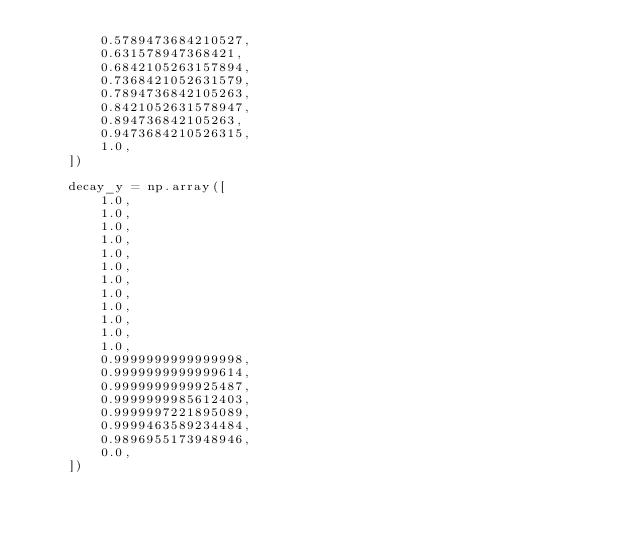<code> <loc_0><loc_0><loc_500><loc_500><_Python_>        0.5789473684210527,
        0.631578947368421,
        0.6842105263157894,
        0.7368421052631579,
        0.7894736842105263,
        0.8421052631578947,
        0.894736842105263,
        0.9473684210526315,
        1.0,
    ])

    decay_y = np.array([
        1.0,
        1.0,
        1.0,
        1.0,
        1.0,
        1.0,
        1.0,
        1.0,
        1.0,
        1.0,
        1.0,
        1.0,
        0.9999999999999998,
        0.9999999999999614,
        0.9999999999925487,
        0.9999999985612403,
        0.9999997221895089,
        0.9999463589234484,
        0.9896955173948946,
        0.0,
    ])
</code> 